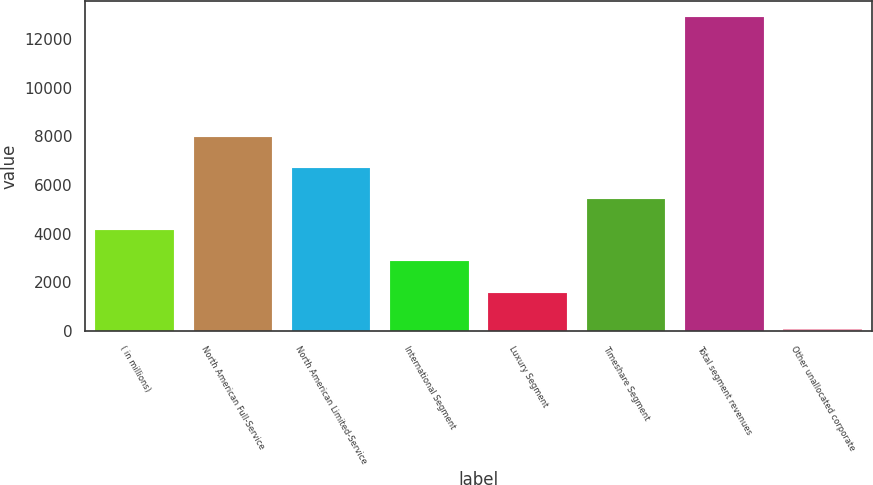<chart> <loc_0><loc_0><loc_500><loc_500><bar_chart><fcel>( in millions)<fcel>North American Full-Service<fcel>North American Limited-Service<fcel>International Segment<fcel>Luxury Segment<fcel>Timeshare Segment<fcel>Total segment revenues<fcel>Other unallocated corporate<nl><fcel>4141.6<fcel>7990<fcel>6707.2<fcel>2858.8<fcel>1576<fcel>5424.4<fcel>12909<fcel>81<nl></chart> 